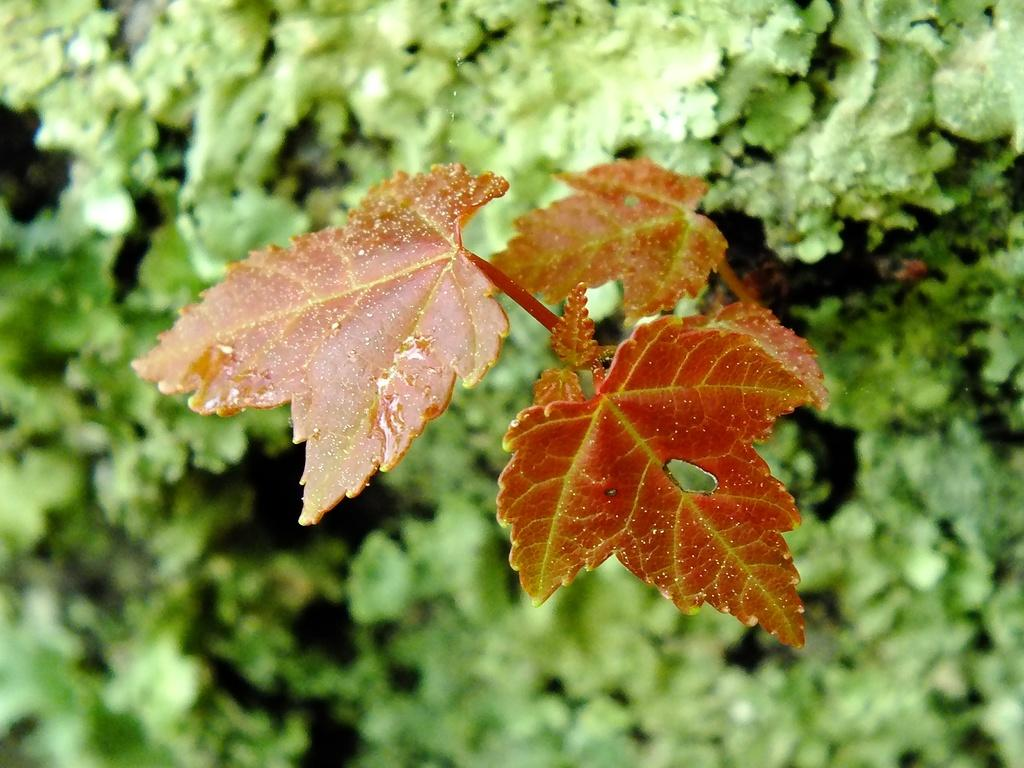What is located in the center of the image? There are leaves in the center of the image. What type of living organisms can be seen in the image? There are plants in the image. What number is written on the match in the image? There is no match present in the image, so it is not possible to determine if a number is written on it. 